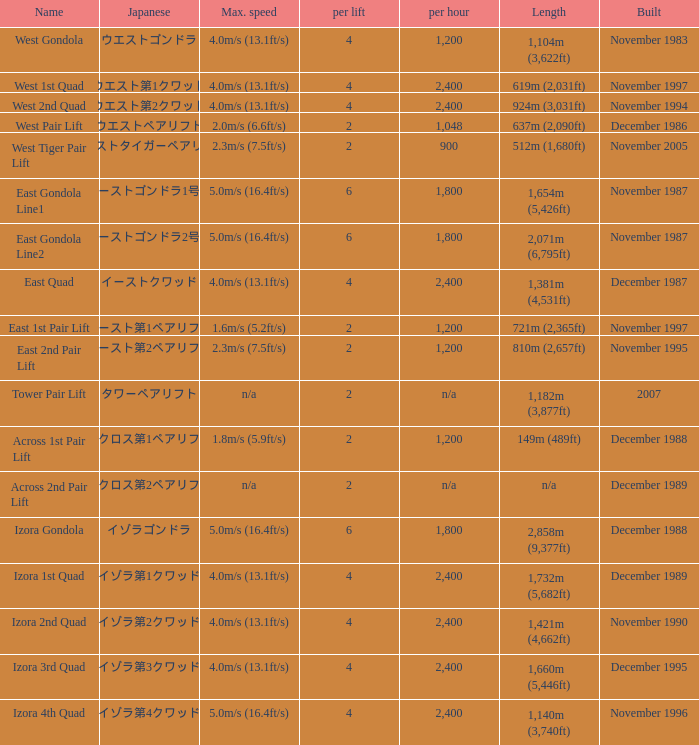How heavy is the  maximum 6.0. 